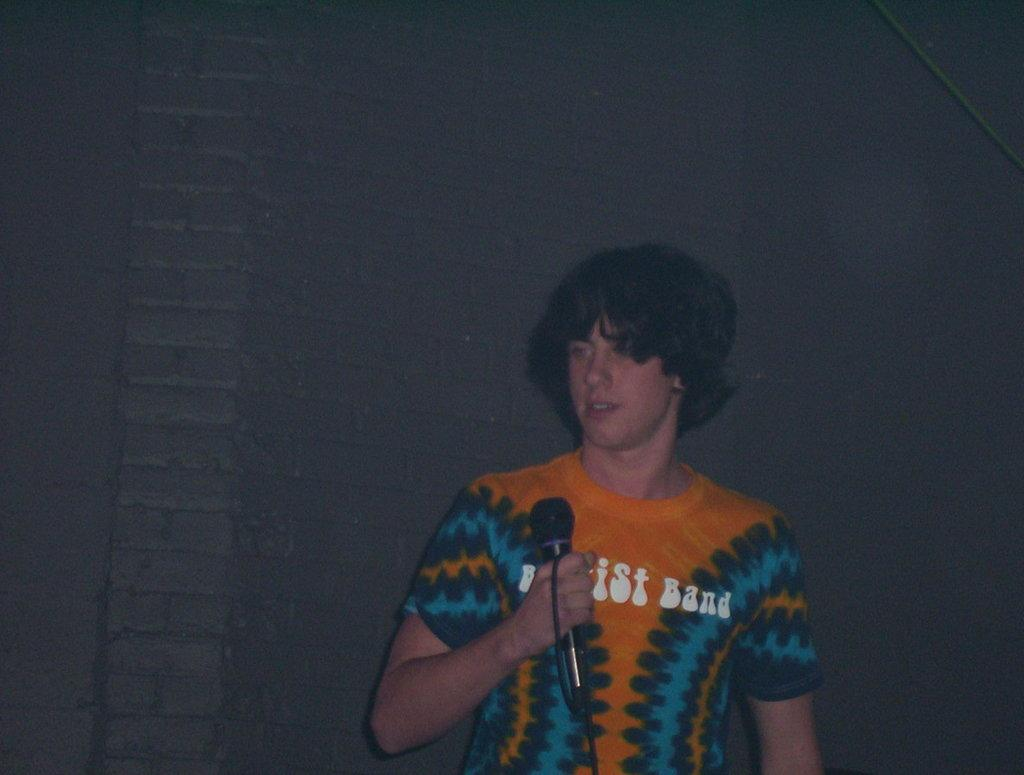What is the color of the background in the image? The background of the image is dark. What type of wall can be seen in the image? There is a wall with bricks in the image. Who is present in the image? There is a man in the image. What is the man wearing? The man is wearing a t-shirt. What is the man doing in the image? The man is standing and holding a microphone in his hand. Is it raining in the image? There is no indication of rain in the image; the background is dark, but it does not necessarily imply rain. 